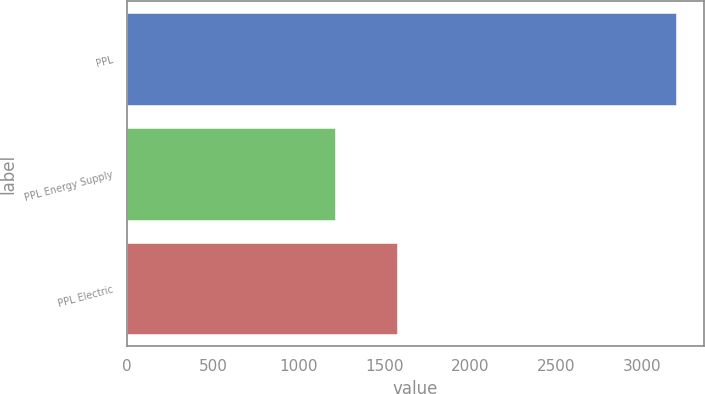<chart> <loc_0><loc_0><loc_500><loc_500><bar_chart><fcel>PPL<fcel>PPL Energy Supply<fcel>PPL Electric<nl><fcel>3200<fcel>1210<fcel>1570<nl></chart> 